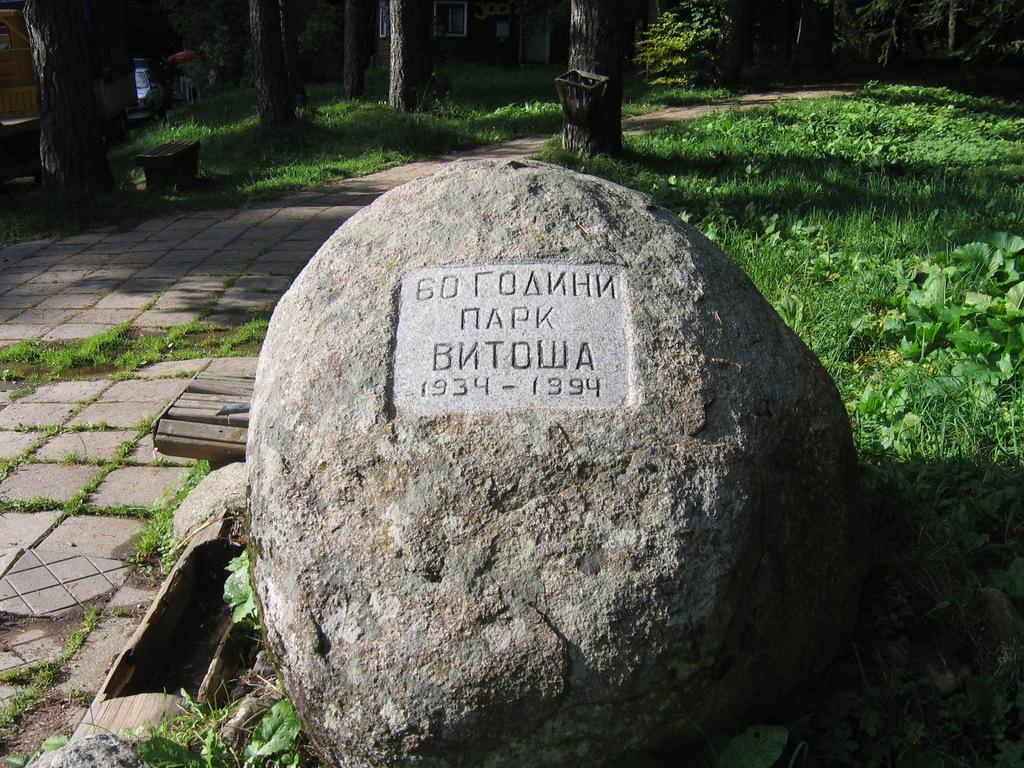What is the main subject in the picture? There is a rock in the picture. Is there any text or message on the rock? Yes, something is written on the rock. What can be seen in the background of the picture? There are trees, plants, grass, and other objects visible in the background of the picture. What type of food is being prepared on the rock in the image? There is no food or cooking activity present in the image; it features a rock with something written on it. 